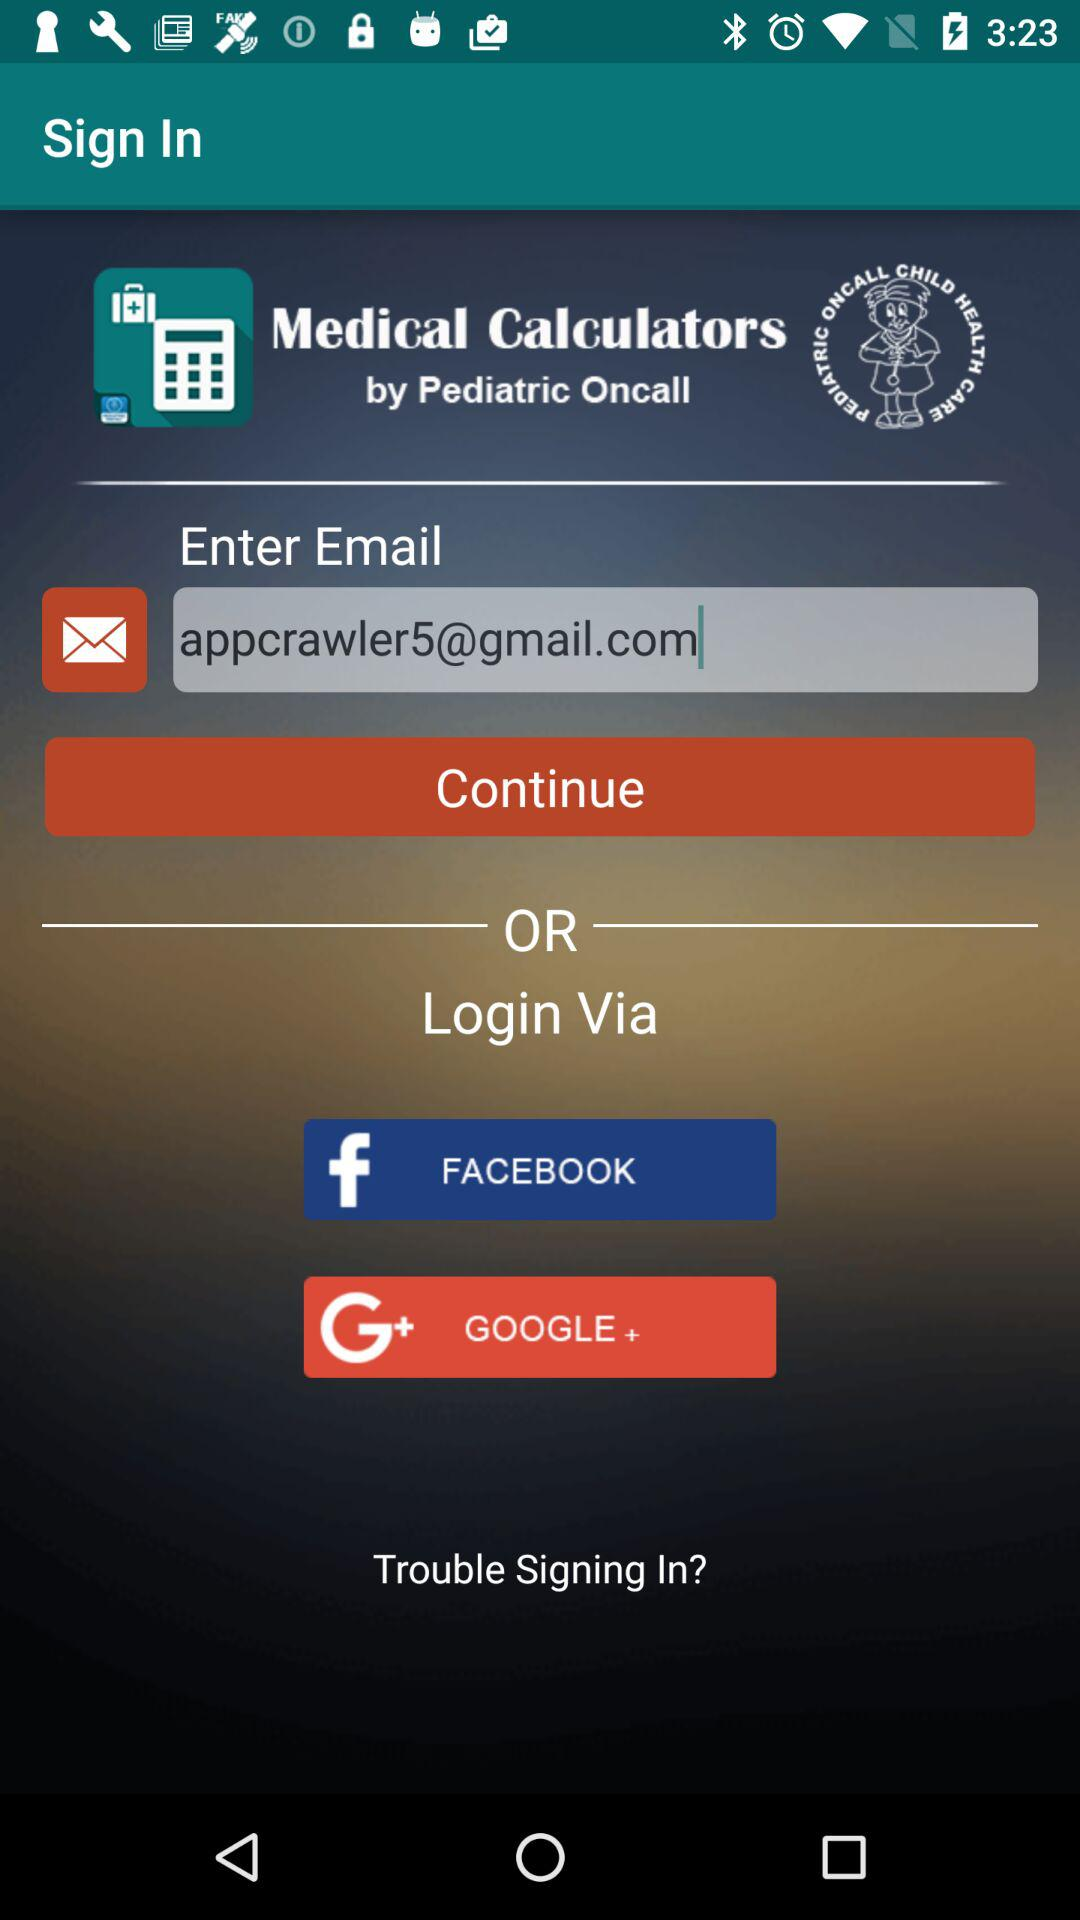What is the name of the application? The name of the application is "Medical Calculators". 